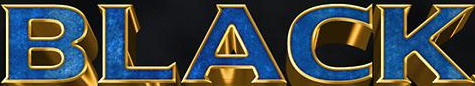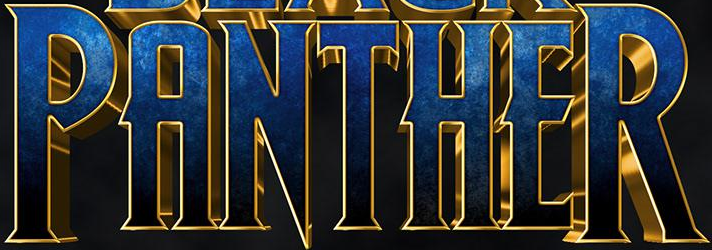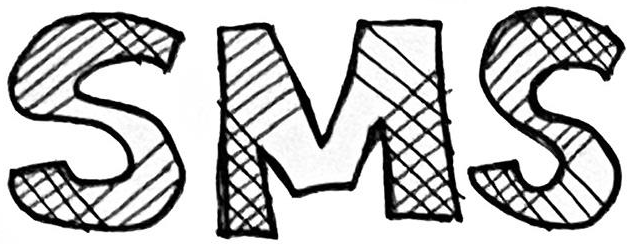What words can you see in these images in sequence, separated by a semicolon? BLACK; PANTHER; SMS 